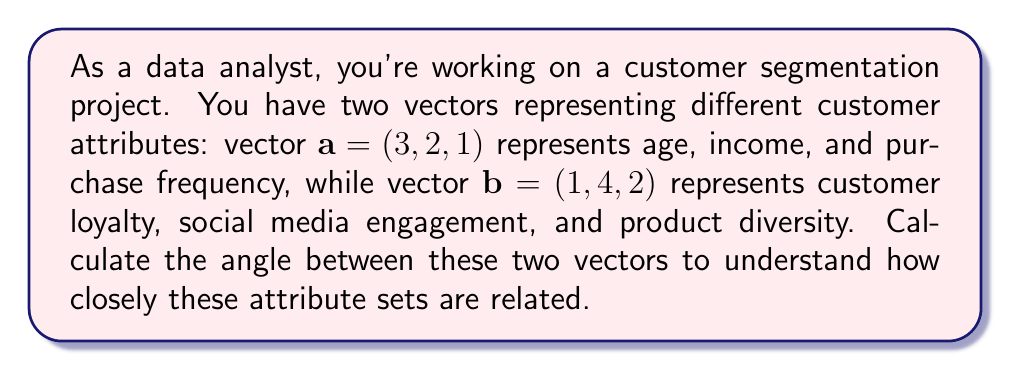Provide a solution to this math problem. To find the angle between two vectors, we can use the dot product formula:

$$\cos \theta = \frac{\mathbf{a} \cdot \mathbf{b}}{|\mathbf{a}||\mathbf{b}|}$$

Where $\mathbf{a} \cdot \mathbf{b}$ is the dot product of the vectors, and $|\mathbf{a}|$ and $|\mathbf{b}|$ are the magnitudes of vectors $\mathbf{a}$ and $\mathbf{b}$ respectively.

Step 1: Calculate the dot product $\mathbf{a} \cdot \mathbf{b}$
$$\mathbf{a} \cdot \mathbf{b} = (3)(1) + (2)(4) + (1)(2) = 3 + 8 + 2 = 13$$

Step 2: Calculate the magnitudes $|\mathbf{a}|$ and $|\mathbf{b}|$
$$|\mathbf{a}| = \sqrt{3^2 + 2^2 + 1^2} = \sqrt{14}$$
$$|\mathbf{b}| = \sqrt{1^2 + 4^2 + 2^2} = \sqrt{21}$$

Step 3: Apply the formula
$$\cos \theta = \frac{13}{\sqrt{14}\sqrt{21}}$$

Step 4: Simplify
$$\cos \theta = \frac{13}{\sqrt{294}} = \frac{13}{\sqrt{2} \cdot \sqrt{147}}$$

Step 5: Calculate the angle using the inverse cosine function
$$\theta = \arccos\left(\frac{13}{\sqrt{2} \cdot \sqrt{147}}\right)$$

Using a calculator, we can determine that:
$$\theta \approx 0.5365 \text{ radians}$$

To convert to degrees, multiply by $\frac{180}{\pi}$:
$$\theta \approx 0.5365 \cdot \frac{180}{\pi} \approx 30.74°$$
Answer: The angle between the two vectors representing different customer attributes is approximately 30.74°. 